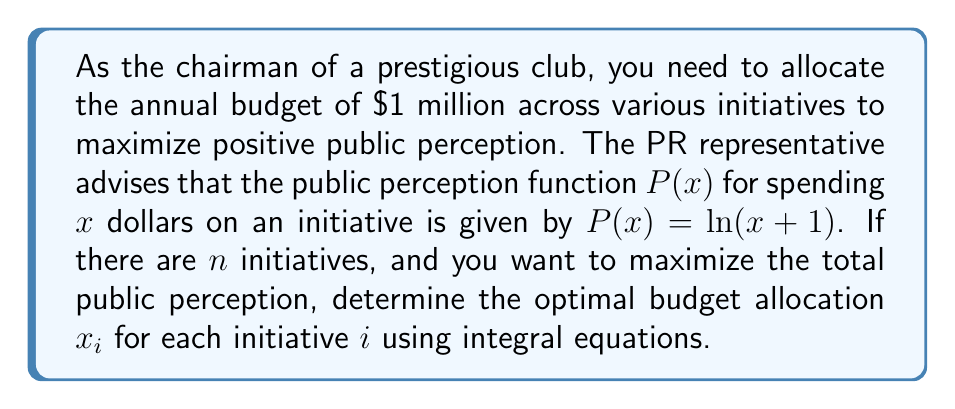Can you answer this question? Let's approach this step-by-step:

1) The total public perception is the sum of perceptions for each initiative:
   $$\text{Total Perception} = \sum_{i=1}^n P(x_i) = \sum_{i=1}^n \ln(x_i+1)$$

2) We want to maximize this subject to the constraint that the total budget is $1 million:
   $$\sum_{i=1}^n x_i = 1,000,000$$

3) This is an optimization problem that can be solved using the method of Lagrange multipliers. Let's define the Lagrangian:
   $$L = \sum_{i=1}^n \ln(x_i+1) - \lambda(\sum_{i=1}^n x_i - 1,000,000)$$

4) For the optimal solution, we need:
   $$\frac{\partial L}{\partial x_i} = \frac{1}{x_i+1} - \lambda = 0$$
   $$\frac{\partial L}{\partial \lambda} = \sum_{i=1}^n x_i - 1,000,000 = 0$$

5) From the first equation:
   $$x_i + 1 = \frac{1}{\lambda}$$
   $$x_i = \frac{1}{\lambda} - 1$$

6) This means all $x_i$ are equal. Let's call this common value $x$. Then:
   $$nx = 1,000,000$$
   $$x = \frac{1,000,000}{n}$$

7) Therefore, the optimal allocation is to divide the budget equally among all initiatives.

8) We can verify this using integral equations. If we treat the initiatives as a continuous distribution, we can write:
   $$\int_0^n x(t) dt = 1,000,000$$
   where $x(t)$ is the budget allocation function.

9) Given the result from step 6, we know $x(t)$ is a constant function:
   $$x(t) = \frac{1,000,000}{n}$$

10) Indeed, this satisfies our integral equation:
    $$\int_0^n \frac{1,000,000}{n} dt = 1,000,000$$
Answer: $x_i = \frac{1,000,000}{n}$ for all $i$ 